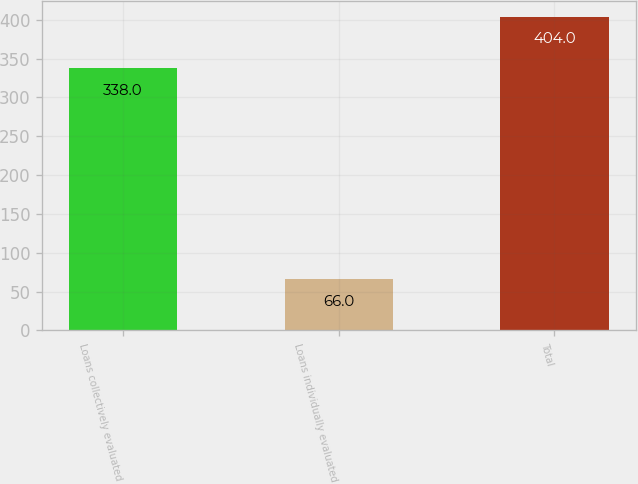<chart> <loc_0><loc_0><loc_500><loc_500><bar_chart><fcel>Loans collectively evaluated<fcel>Loans individually evaluated<fcel>Total<nl><fcel>338<fcel>66<fcel>404<nl></chart> 